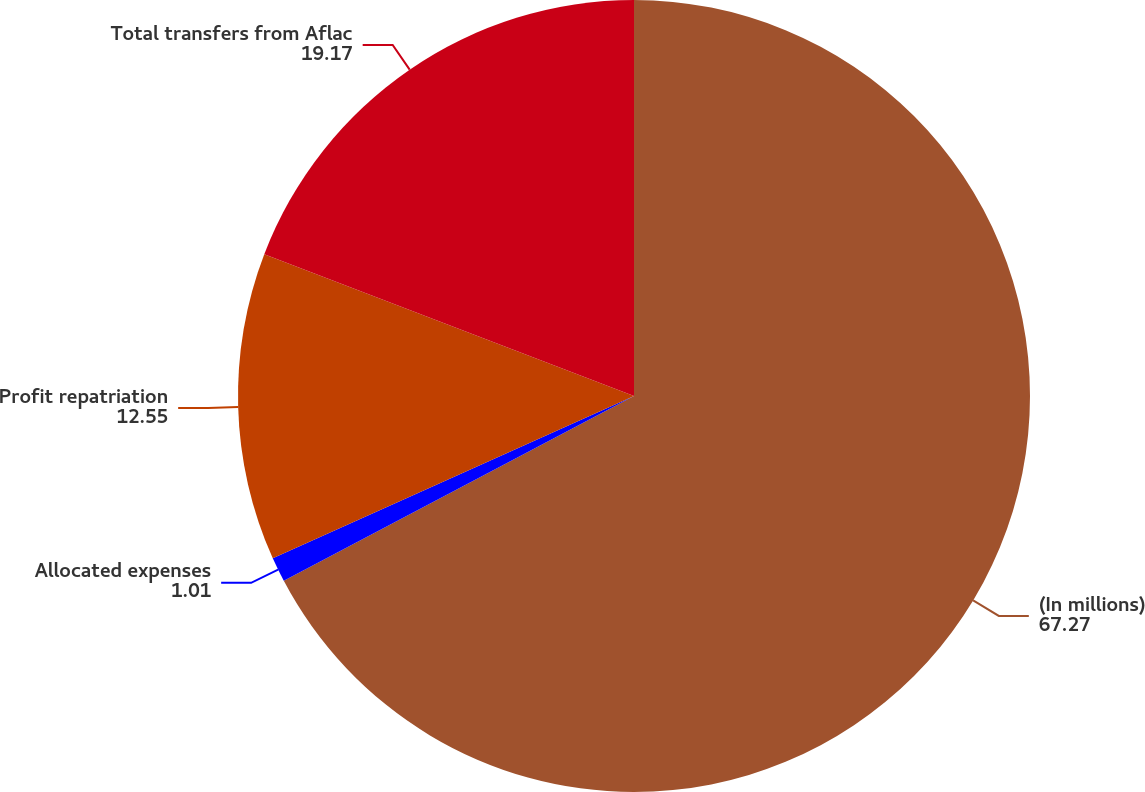Convert chart. <chart><loc_0><loc_0><loc_500><loc_500><pie_chart><fcel>(In millions)<fcel>Allocated expenses<fcel>Profit repatriation<fcel>Total transfers from Aflac<nl><fcel>67.27%<fcel>1.01%<fcel>12.55%<fcel>19.17%<nl></chart> 